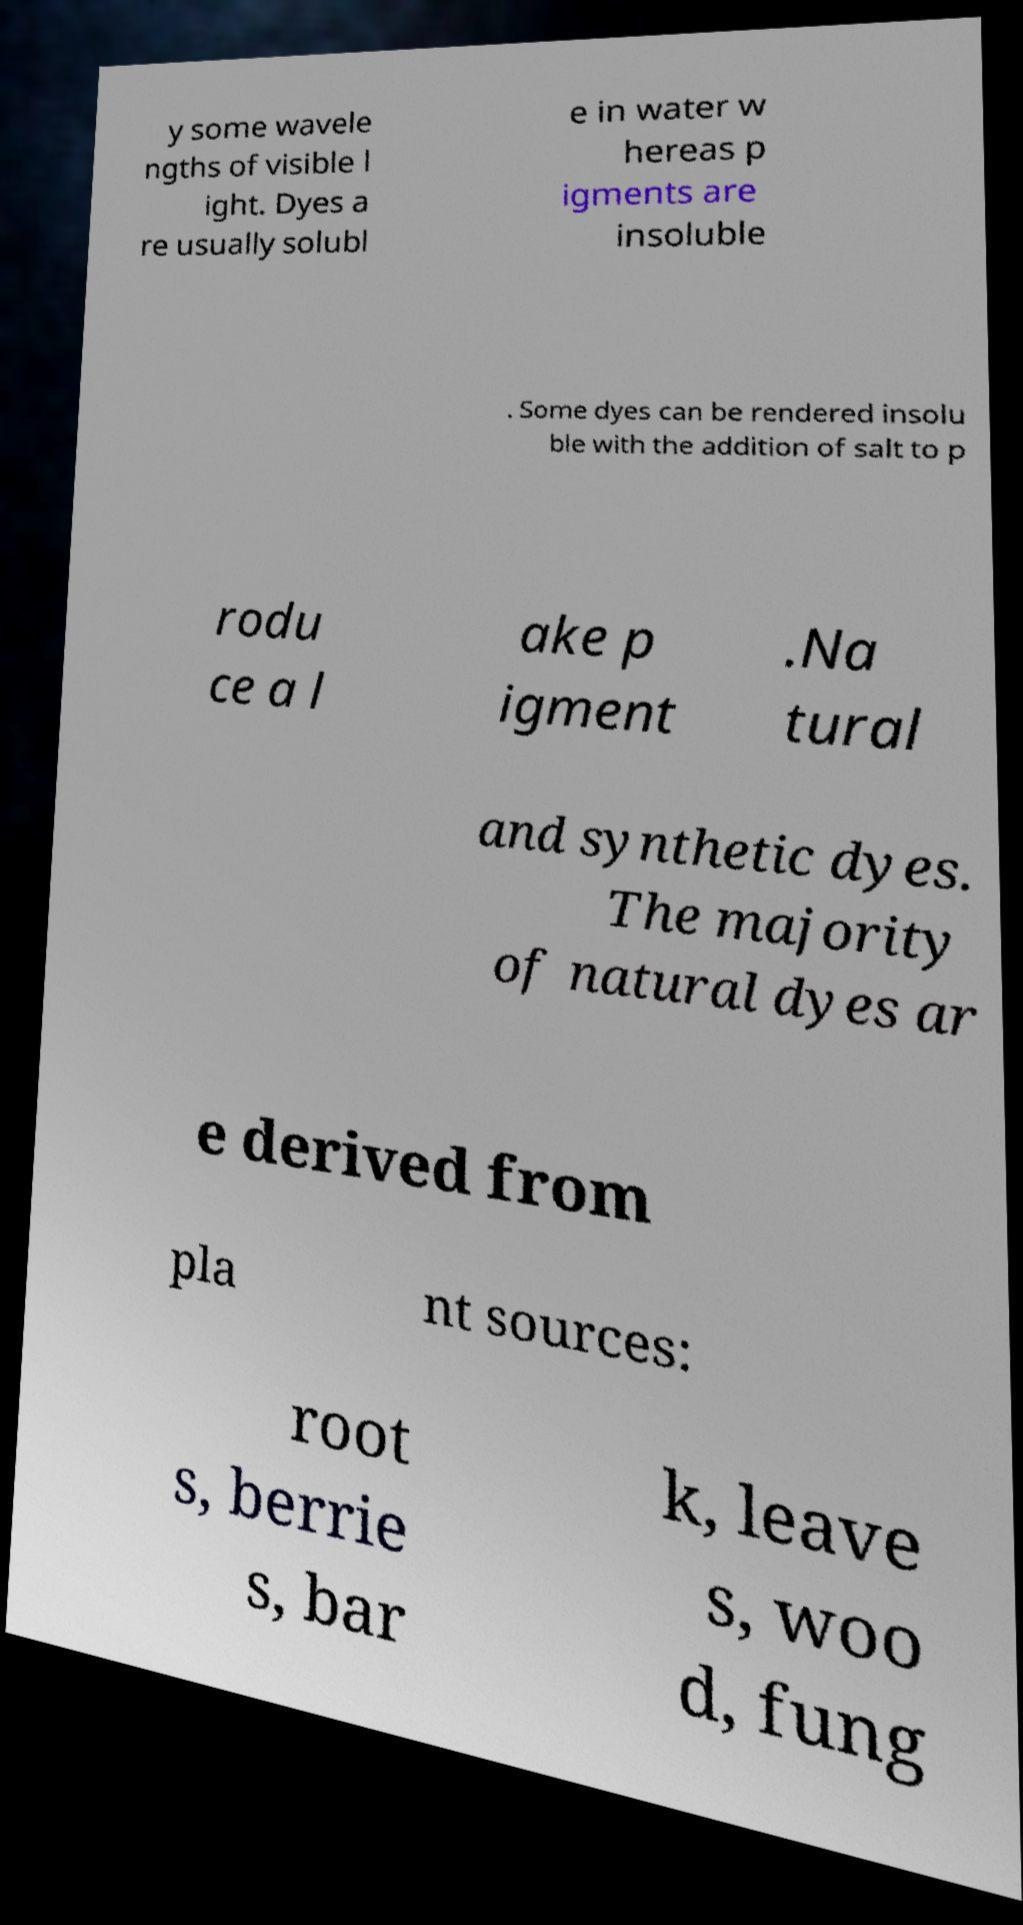Could you assist in decoding the text presented in this image and type it out clearly? y some wavele ngths of visible l ight. Dyes a re usually solubl e in water w hereas p igments are insoluble . Some dyes can be rendered insolu ble with the addition of salt to p rodu ce a l ake p igment .Na tural and synthetic dyes. The majority of natural dyes ar e derived from pla nt sources: root s, berrie s, bar k, leave s, woo d, fung 